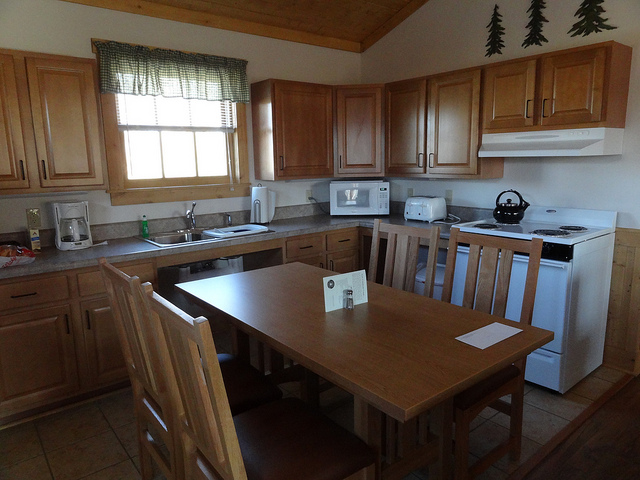<image>What electronic device hangs from the far right wall? There is no electronic device hanging on the far right wall. What design has the table cover? It is uncertain what design the table cover has. It may not have a design or could potentially have a wood or modern design. What electronic device hangs from the far right wall? I don't know what electronic device hangs from the far right wall. What design has the table cover? The design of the table cover is unknown. It can be wood grain, wood, solid or modern. 